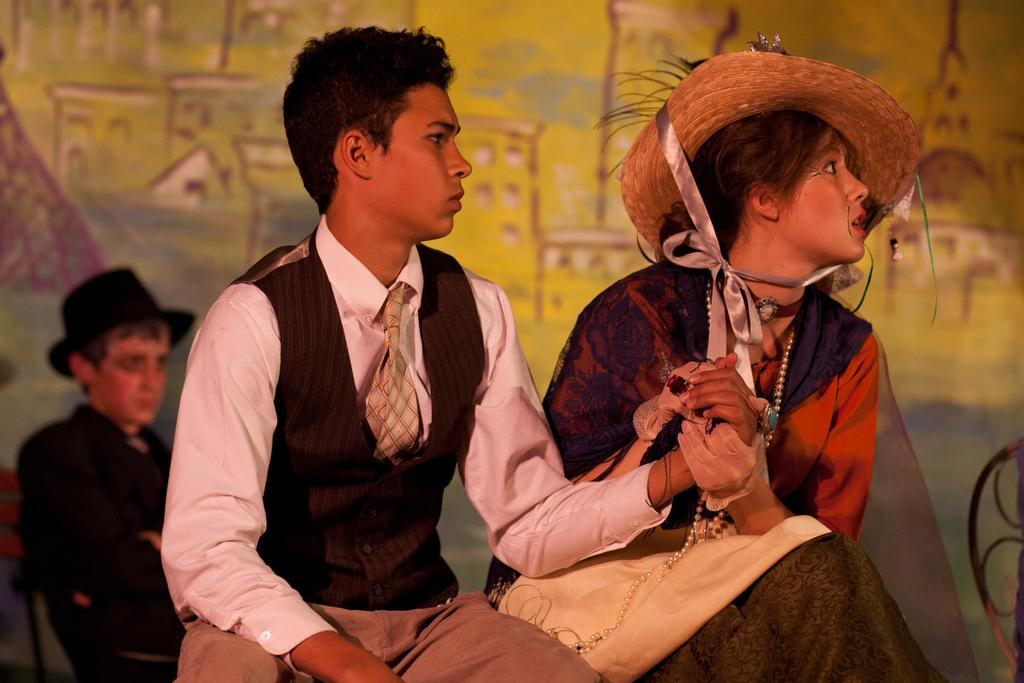How many people are in the image? There are three persons in the image. What are the persons doing in the image? The persons are sitting on chairs. What can be seen in the background of the image? There is a wall in the background of the image, and wall paintings are present on the wall. Where might this image have been taken? The image may have been taken in a hall. What type of crown is the person wearing in the image? There is no crown present in the image; the persons are sitting on chairs and there is no mention of any crowns. 